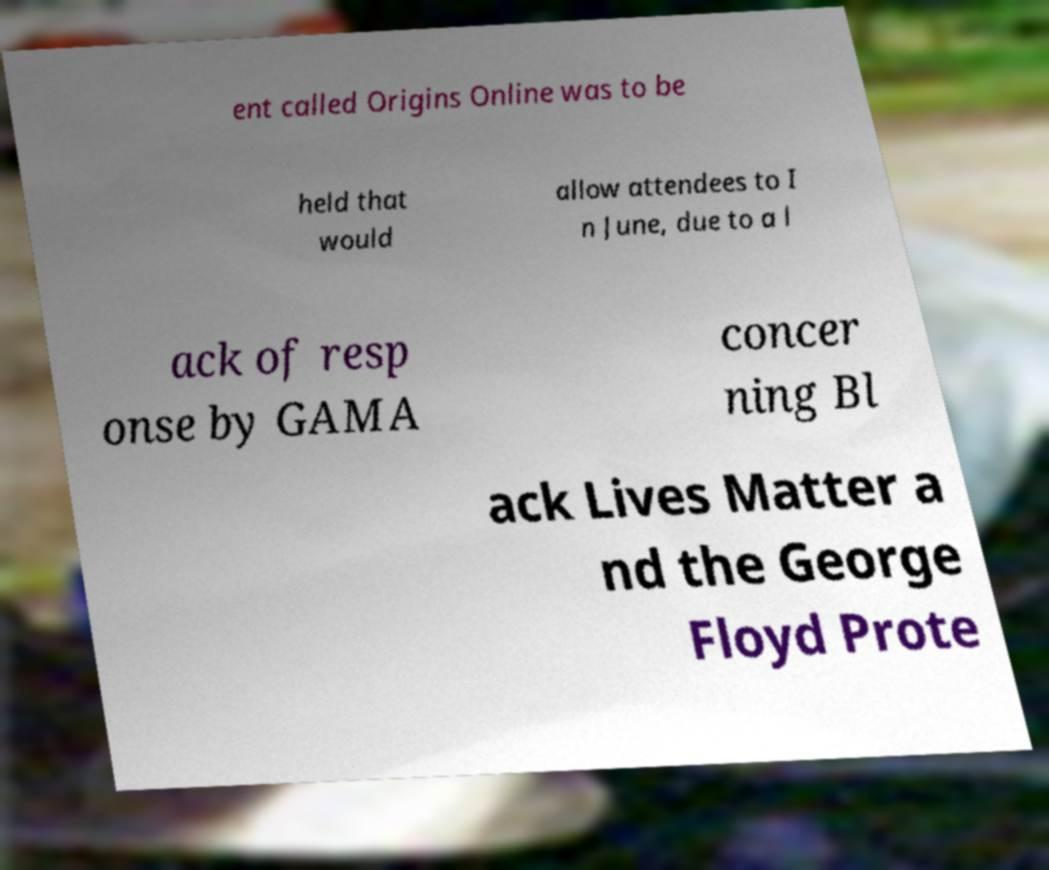Can you read and provide the text displayed in the image?This photo seems to have some interesting text. Can you extract and type it out for me? ent called Origins Online was to be held that would allow attendees to I n June, due to a l ack of resp onse by GAMA concer ning Bl ack Lives Matter a nd the George Floyd Prote 